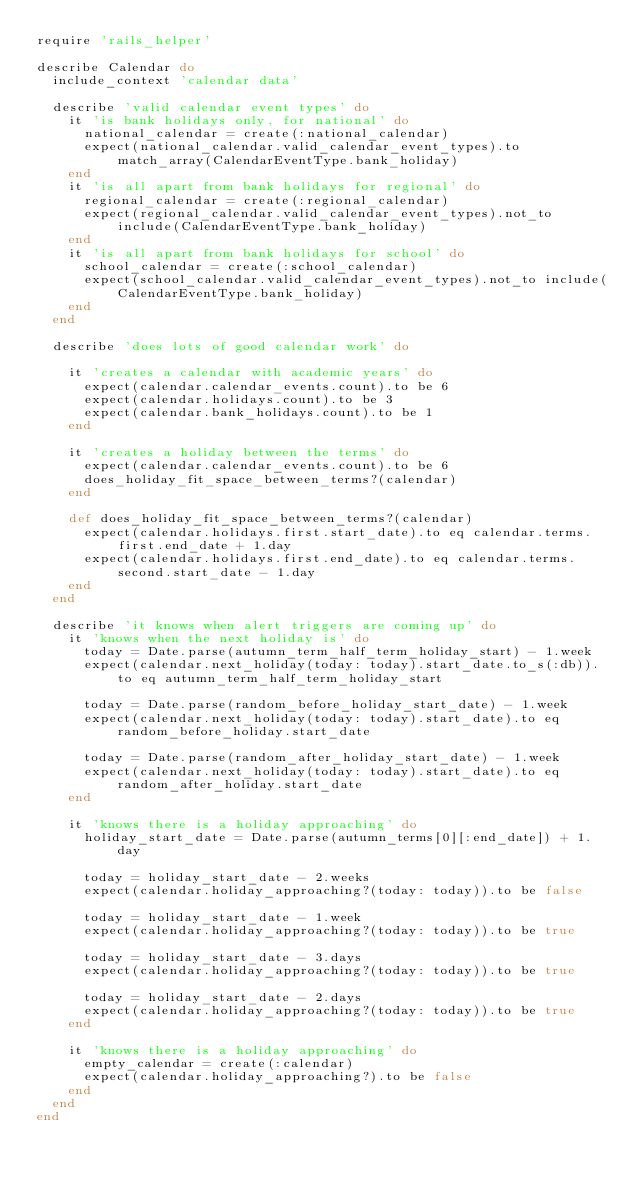<code> <loc_0><loc_0><loc_500><loc_500><_Ruby_>require 'rails_helper'

describe Calendar do
  include_context 'calendar data'

  describe 'valid calendar event types' do
    it 'is bank holidays only, for national' do
      national_calendar = create(:national_calendar)
      expect(national_calendar.valid_calendar_event_types).to match_array(CalendarEventType.bank_holiday)
    end
    it 'is all apart from bank holidays for regional' do
      regional_calendar = create(:regional_calendar)
      expect(regional_calendar.valid_calendar_event_types).not_to include(CalendarEventType.bank_holiday)
    end
    it 'is all apart from bank holidays for school' do
      school_calendar = create(:school_calendar)
      expect(school_calendar.valid_calendar_event_types).not_to include(CalendarEventType.bank_holiday)
    end
  end

  describe 'does lots of good calendar work' do

    it 'creates a calendar with academic years' do
      expect(calendar.calendar_events.count).to be 6
      expect(calendar.holidays.count).to be 3
      expect(calendar.bank_holidays.count).to be 1
    end

    it 'creates a holiday between the terms' do
      expect(calendar.calendar_events.count).to be 6
      does_holiday_fit_space_between_terms?(calendar)
    end

    def does_holiday_fit_space_between_terms?(calendar)
      expect(calendar.holidays.first.start_date).to eq calendar.terms.first.end_date + 1.day
      expect(calendar.holidays.first.end_date).to eq calendar.terms.second.start_date - 1.day
    end
  end

  describe 'it knows when alert triggers are coming up' do
    it 'knows when the next holiday is' do
      today = Date.parse(autumn_term_half_term_holiday_start) - 1.week
      expect(calendar.next_holiday(today: today).start_date.to_s(:db)).to eq autumn_term_half_term_holiday_start

      today = Date.parse(random_before_holiday_start_date) - 1.week
      expect(calendar.next_holiday(today: today).start_date).to eq random_before_holiday.start_date

      today = Date.parse(random_after_holiday_start_date) - 1.week
      expect(calendar.next_holiday(today: today).start_date).to eq random_after_holiday.start_date
    end

    it 'knows there is a holiday approaching' do
      holiday_start_date = Date.parse(autumn_terms[0][:end_date]) + 1.day

      today = holiday_start_date - 2.weeks
      expect(calendar.holiday_approaching?(today: today)).to be false

      today = holiday_start_date - 1.week
      expect(calendar.holiday_approaching?(today: today)).to be true

      today = holiday_start_date - 3.days
      expect(calendar.holiday_approaching?(today: today)).to be true

      today = holiday_start_date - 2.days
      expect(calendar.holiday_approaching?(today: today)).to be true
    end

    it 'knows there is a holiday approaching' do
      empty_calendar = create(:calendar)
      expect(calendar.holiday_approaching?).to be false
    end
  end
end
</code> 